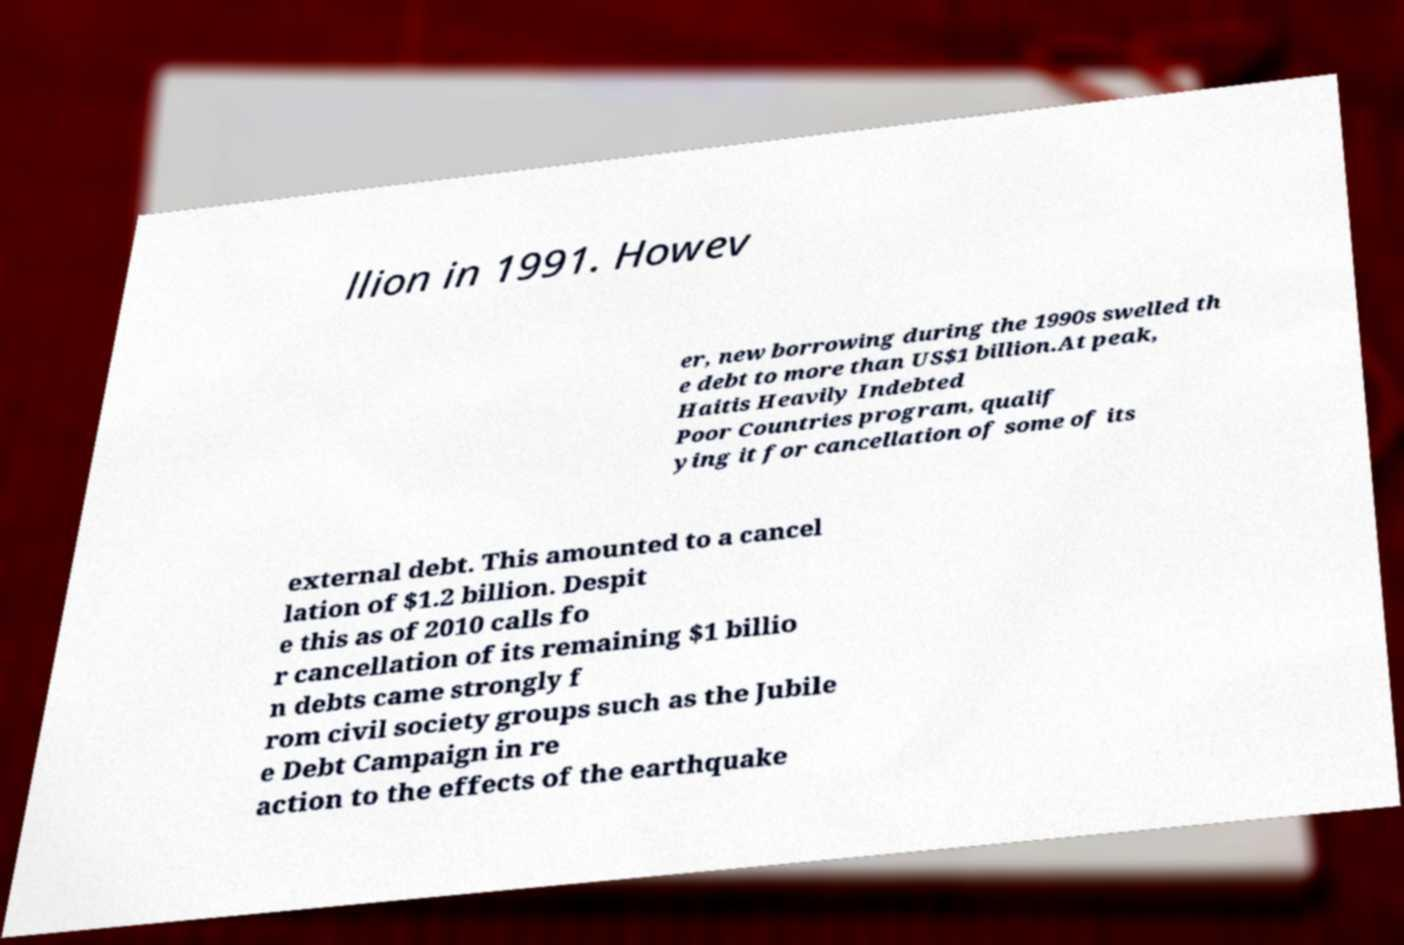There's text embedded in this image that I need extracted. Can you transcribe it verbatim? llion in 1991. Howev er, new borrowing during the 1990s swelled th e debt to more than US$1 billion.At peak, Haitis Heavily Indebted Poor Countries program, qualif ying it for cancellation of some of its external debt. This amounted to a cancel lation of $1.2 billion. Despit e this as of 2010 calls fo r cancellation of its remaining $1 billio n debts came strongly f rom civil society groups such as the Jubile e Debt Campaign in re action to the effects of the earthquake 